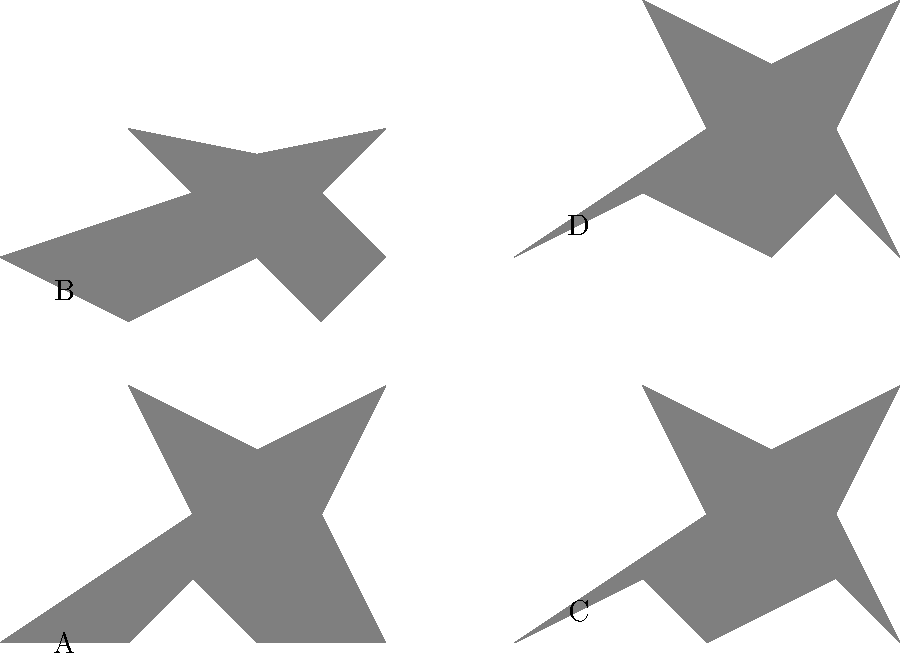Identify which of the bird silhouettes (A, B, C, or D) represents a side view of a bird in flight. To identify the side view of a bird in flight, we need to analyze each silhouette:

1. Silhouette A: This shows a bird from above, with wings spread out horizontally. The head is visible at the front, and the tail at the back.

2. Silhouette B: This represents a frontal view of a bird, likely perched. The head is at the top, and the body widens towards the bottom.

3. Silhouette C: This silhouette shows a side view of a bird in flight. We can see:
   - The head and beak pointing forward
   - The body elongated horizontally
   - One wing visible, raised above the body
   - The tail visible at the back

4. Silhouette D: This shows a bird from below, with wings spread out. The head is less distinct, and the tail is visible at the back.

The side view of a bird in flight is characterized by its horizontal orientation, visible head and beak at one end, one raised wing, and a tail at the other end. These features are most evident in silhouette C.
Answer: C 